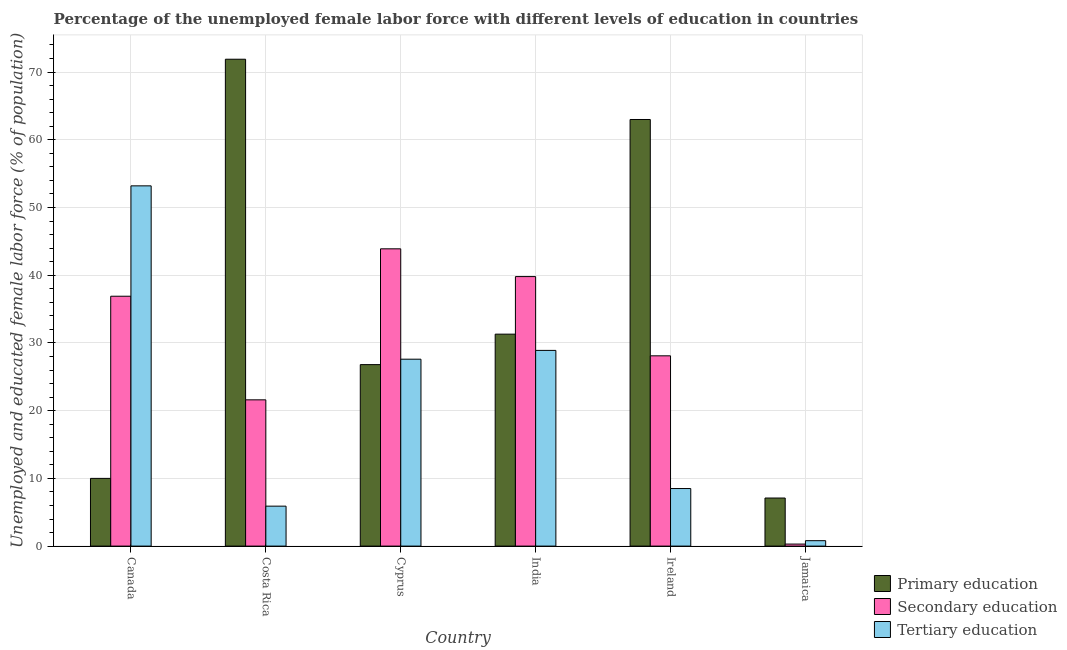How many different coloured bars are there?
Your answer should be compact. 3. How many groups of bars are there?
Your answer should be compact. 6. Are the number of bars on each tick of the X-axis equal?
Your response must be concise. Yes. What is the label of the 1st group of bars from the left?
Offer a terse response. Canada. In how many cases, is the number of bars for a given country not equal to the number of legend labels?
Ensure brevity in your answer.  0. What is the percentage of female labor force who received primary education in Jamaica?
Offer a very short reply. 7.1. Across all countries, what is the maximum percentage of female labor force who received tertiary education?
Your response must be concise. 53.2. Across all countries, what is the minimum percentage of female labor force who received tertiary education?
Provide a short and direct response. 0.8. In which country was the percentage of female labor force who received secondary education minimum?
Offer a terse response. Jamaica. What is the total percentage of female labor force who received secondary education in the graph?
Your answer should be compact. 170.6. What is the difference between the percentage of female labor force who received secondary education in Costa Rica and that in Ireland?
Your answer should be compact. -6.5. What is the difference between the percentage of female labor force who received tertiary education in India and the percentage of female labor force who received primary education in Ireland?
Give a very brief answer. -34.1. What is the average percentage of female labor force who received tertiary education per country?
Ensure brevity in your answer.  20.82. What is the difference between the percentage of female labor force who received secondary education and percentage of female labor force who received tertiary education in Costa Rica?
Your answer should be compact. 15.7. In how many countries, is the percentage of female labor force who received tertiary education greater than 18 %?
Keep it short and to the point. 3. What is the ratio of the percentage of female labor force who received tertiary education in India to that in Ireland?
Give a very brief answer. 3.4. Is the difference between the percentage of female labor force who received tertiary education in Costa Rica and Jamaica greater than the difference between the percentage of female labor force who received secondary education in Costa Rica and Jamaica?
Make the answer very short. No. What is the difference between the highest and the second highest percentage of female labor force who received secondary education?
Offer a terse response. 4.1. What is the difference between the highest and the lowest percentage of female labor force who received secondary education?
Offer a very short reply. 43.6. In how many countries, is the percentage of female labor force who received secondary education greater than the average percentage of female labor force who received secondary education taken over all countries?
Provide a succinct answer. 3. What does the 2nd bar from the left in Jamaica represents?
Your answer should be very brief. Secondary education. Is it the case that in every country, the sum of the percentage of female labor force who received primary education and percentage of female labor force who received secondary education is greater than the percentage of female labor force who received tertiary education?
Your response must be concise. No. How many bars are there?
Your answer should be very brief. 18. Does the graph contain any zero values?
Your answer should be compact. No. Where does the legend appear in the graph?
Make the answer very short. Bottom right. How are the legend labels stacked?
Give a very brief answer. Vertical. What is the title of the graph?
Offer a very short reply. Percentage of the unemployed female labor force with different levels of education in countries. Does "Ages 65 and above" appear as one of the legend labels in the graph?
Your response must be concise. No. What is the label or title of the Y-axis?
Keep it short and to the point. Unemployed and educated female labor force (% of population). What is the Unemployed and educated female labor force (% of population) of Secondary education in Canada?
Offer a very short reply. 36.9. What is the Unemployed and educated female labor force (% of population) in Tertiary education in Canada?
Provide a succinct answer. 53.2. What is the Unemployed and educated female labor force (% of population) in Primary education in Costa Rica?
Make the answer very short. 71.9. What is the Unemployed and educated female labor force (% of population) in Secondary education in Costa Rica?
Offer a very short reply. 21.6. What is the Unemployed and educated female labor force (% of population) of Tertiary education in Costa Rica?
Provide a succinct answer. 5.9. What is the Unemployed and educated female labor force (% of population) in Primary education in Cyprus?
Keep it short and to the point. 26.8. What is the Unemployed and educated female labor force (% of population) of Secondary education in Cyprus?
Your answer should be very brief. 43.9. What is the Unemployed and educated female labor force (% of population) of Tertiary education in Cyprus?
Provide a succinct answer. 27.6. What is the Unemployed and educated female labor force (% of population) in Primary education in India?
Provide a short and direct response. 31.3. What is the Unemployed and educated female labor force (% of population) in Secondary education in India?
Give a very brief answer. 39.8. What is the Unemployed and educated female labor force (% of population) in Tertiary education in India?
Offer a very short reply. 28.9. What is the Unemployed and educated female labor force (% of population) in Secondary education in Ireland?
Give a very brief answer. 28.1. What is the Unemployed and educated female labor force (% of population) in Primary education in Jamaica?
Make the answer very short. 7.1. What is the Unemployed and educated female labor force (% of population) of Secondary education in Jamaica?
Make the answer very short. 0.3. What is the Unemployed and educated female labor force (% of population) of Tertiary education in Jamaica?
Ensure brevity in your answer.  0.8. Across all countries, what is the maximum Unemployed and educated female labor force (% of population) of Primary education?
Your answer should be compact. 71.9. Across all countries, what is the maximum Unemployed and educated female labor force (% of population) of Secondary education?
Your answer should be very brief. 43.9. Across all countries, what is the maximum Unemployed and educated female labor force (% of population) of Tertiary education?
Your response must be concise. 53.2. Across all countries, what is the minimum Unemployed and educated female labor force (% of population) of Primary education?
Your response must be concise. 7.1. Across all countries, what is the minimum Unemployed and educated female labor force (% of population) in Secondary education?
Provide a short and direct response. 0.3. Across all countries, what is the minimum Unemployed and educated female labor force (% of population) of Tertiary education?
Make the answer very short. 0.8. What is the total Unemployed and educated female labor force (% of population) in Primary education in the graph?
Offer a very short reply. 210.1. What is the total Unemployed and educated female labor force (% of population) of Secondary education in the graph?
Provide a short and direct response. 170.6. What is the total Unemployed and educated female labor force (% of population) of Tertiary education in the graph?
Your response must be concise. 124.9. What is the difference between the Unemployed and educated female labor force (% of population) in Primary education in Canada and that in Costa Rica?
Make the answer very short. -61.9. What is the difference between the Unemployed and educated female labor force (% of population) in Secondary education in Canada and that in Costa Rica?
Your answer should be compact. 15.3. What is the difference between the Unemployed and educated female labor force (% of population) in Tertiary education in Canada and that in Costa Rica?
Make the answer very short. 47.3. What is the difference between the Unemployed and educated female labor force (% of population) in Primary education in Canada and that in Cyprus?
Make the answer very short. -16.8. What is the difference between the Unemployed and educated female labor force (% of population) of Tertiary education in Canada and that in Cyprus?
Provide a short and direct response. 25.6. What is the difference between the Unemployed and educated female labor force (% of population) in Primary education in Canada and that in India?
Ensure brevity in your answer.  -21.3. What is the difference between the Unemployed and educated female labor force (% of population) of Secondary education in Canada and that in India?
Offer a very short reply. -2.9. What is the difference between the Unemployed and educated female labor force (% of population) of Tertiary education in Canada and that in India?
Offer a very short reply. 24.3. What is the difference between the Unemployed and educated female labor force (% of population) in Primary education in Canada and that in Ireland?
Ensure brevity in your answer.  -53. What is the difference between the Unemployed and educated female labor force (% of population) in Tertiary education in Canada and that in Ireland?
Your answer should be very brief. 44.7. What is the difference between the Unemployed and educated female labor force (% of population) in Secondary education in Canada and that in Jamaica?
Provide a succinct answer. 36.6. What is the difference between the Unemployed and educated female labor force (% of population) of Tertiary education in Canada and that in Jamaica?
Offer a very short reply. 52.4. What is the difference between the Unemployed and educated female labor force (% of population) in Primary education in Costa Rica and that in Cyprus?
Offer a terse response. 45.1. What is the difference between the Unemployed and educated female labor force (% of population) of Secondary education in Costa Rica and that in Cyprus?
Keep it short and to the point. -22.3. What is the difference between the Unemployed and educated female labor force (% of population) of Tertiary education in Costa Rica and that in Cyprus?
Provide a short and direct response. -21.7. What is the difference between the Unemployed and educated female labor force (% of population) in Primary education in Costa Rica and that in India?
Provide a succinct answer. 40.6. What is the difference between the Unemployed and educated female labor force (% of population) of Secondary education in Costa Rica and that in India?
Provide a succinct answer. -18.2. What is the difference between the Unemployed and educated female labor force (% of population) in Primary education in Costa Rica and that in Ireland?
Your answer should be very brief. 8.9. What is the difference between the Unemployed and educated female labor force (% of population) of Primary education in Costa Rica and that in Jamaica?
Give a very brief answer. 64.8. What is the difference between the Unemployed and educated female labor force (% of population) of Secondary education in Costa Rica and that in Jamaica?
Provide a short and direct response. 21.3. What is the difference between the Unemployed and educated female labor force (% of population) of Tertiary education in Costa Rica and that in Jamaica?
Your response must be concise. 5.1. What is the difference between the Unemployed and educated female labor force (% of population) in Primary education in Cyprus and that in India?
Your answer should be compact. -4.5. What is the difference between the Unemployed and educated female labor force (% of population) in Primary education in Cyprus and that in Ireland?
Your answer should be very brief. -36.2. What is the difference between the Unemployed and educated female labor force (% of population) of Secondary education in Cyprus and that in Jamaica?
Make the answer very short. 43.6. What is the difference between the Unemployed and educated female labor force (% of population) of Tertiary education in Cyprus and that in Jamaica?
Provide a succinct answer. 26.8. What is the difference between the Unemployed and educated female labor force (% of population) of Primary education in India and that in Ireland?
Your response must be concise. -31.7. What is the difference between the Unemployed and educated female labor force (% of population) in Secondary education in India and that in Ireland?
Provide a succinct answer. 11.7. What is the difference between the Unemployed and educated female labor force (% of population) in Tertiary education in India and that in Ireland?
Provide a succinct answer. 20.4. What is the difference between the Unemployed and educated female labor force (% of population) of Primary education in India and that in Jamaica?
Your answer should be very brief. 24.2. What is the difference between the Unemployed and educated female labor force (% of population) of Secondary education in India and that in Jamaica?
Ensure brevity in your answer.  39.5. What is the difference between the Unemployed and educated female labor force (% of population) of Tertiary education in India and that in Jamaica?
Your answer should be compact. 28.1. What is the difference between the Unemployed and educated female labor force (% of population) in Primary education in Ireland and that in Jamaica?
Provide a short and direct response. 55.9. What is the difference between the Unemployed and educated female labor force (% of population) in Secondary education in Ireland and that in Jamaica?
Give a very brief answer. 27.8. What is the difference between the Unemployed and educated female labor force (% of population) of Tertiary education in Ireland and that in Jamaica?
Your answer should be very brief. 7.7. What is the difference between the Unemployed and educated female labor force (% of population) of Primary education in Canada and the Unemployed and educated female labor force (% of population) of Tertiary education in Costa Rica?
Provide a short and direct response. 4.1. What is the difference between the Unemployed and educated female labor force (% of population) in Secondary education in Canada and the Unemployed and educated female labor force (% of population) in Tertiary education in Costa Rica?
Provide a succinct answer. 31. What is the difference between the Unemployed and educated female labor force (% of population) of Primary education in Canada and the Unemployed and educated female labor force (% of population) of Secondary education in Cyprus?
Ensure brevity in your answer.  -33.9. What is the difference between the Unemployed and educated female labor force (% of population) in Primary education in Canada and the Unemployed and educated female labor force (% of population) in Tertiary education in Cyprus?
Give a very brief answer. -17.6. What is the difference between the Unemployed and educated female labor force (% of population) in Primary education in Canada and the Unemployed and educated female labor force (% of population) in Secondary education in India?
Offer a terse response. -29.8. What is the difference between the Unemployed and educated female labor force (% of population) of Primary education in Canada and the Unemployed and educated female labor force (% of population) of Tertiary education in India?
Offer a terse response. -18.9. What is the difference between the Unemployed and educated female labor force (% of population) in Primary education in Canada and the Unemployed and educated female labor force (% of population) in Secondary education in Ireland?
Your response must be concise. -18.1. What is the difference between the Unemployed and educated female labor force (% of population) in Primary education in Canada and the Unemployed and educated female labor force (% of population) in Tertiary education in Ireland?
Provide a succinct answer. 1.5. What is the difference between the Unemployed and educated female labor force (% of population) of Secondary education in Canada and the Unemployed and educated female labor force (% of population) of Tertiary education in Ireland?
Provide a succinct answer. 28.4. What is the difference between the Unemployed and educated female labor force (% of population) of Primary education in Canada and the Unemployed and educated female labor force (% of population) of Secondary education in Jamaica?
Offer a very short reply. 9.7. What is the difference between the Unemployed and educated female labor force (% of population) of Secondary education in Canada and the Unemployed and educated female labor force (% of population) of Tertiary education in Jamaica?
Keep it short and to the point. 36.1. What is the difference between the Unemployed and educated female labor force (% of population) in Primary education in Costa Rica and the Unemployed and educated female labor force (% of population) in Tertiary education in Cyprus?
Provide a short and direct response. 44.3. What is the difference between the Unemployed and educated female labor force (% of population) of Primary education in Costa Rica and the Unemployed and educated female labor force (% of population) of Secondary education in India?
Your answer should be very brief. 32.1. What is the difference between the Unemployed and educated female labor force (% of population) of Primary education in Costa Rica and the Unemployed and educated female labor force (% of population) of Tertiary education in India?
Give a very brief answer. 43. What is the difference between the Unemployed and educated female labor force (% of population) in Primary education in Costa Rica and the Unemployed and educated female labor force (% of population) in Secondary education in Ireland?
Offer a very short reply. 43.8. What is the difference between the Unemployed and educated female labor force (% of population) of Primary education in Costa Rica and the Unemployed and educated female labor force (% of population) of Tertiary education in Ireland?
Offer a very short reply. 63.4. What is the difference between the Unemployed and educated female labor force (% of population) in Primary education in Costa Rica and the Unemployed and educated female labor force (% of population) in Secondary education in Jamaica?
Ensure brevity in your answer.  71.6. What is the difference between the Unemployed and educated female labor force (% of population) of Primary education in Costa Rica and the Unemployed and educated female labor force (% of population) of Tertiary education in Jamaica?
Make the answer very short. 71.1. What is the difference between the Unemployed and educated female labor force (% of population) of Secondary education in Costa Rica and the Unemployed and educated female labor force (% of population) of Tertiary education in Jamaica?
Your answer should be compact. 20.8. What is the difference between the Unemployed and educated female labor force (% of population) in Primary education in Cyprus and the Unemployed and educated female labor force (% of population) in Secondary education in India?
Your answer should be very brief. -13. What is the difference between the Unemployed and educated female labor force (% of population) of Primary education in Cyprus and the Unemployed and educated female labor force (% of population) of Tertiary education in Ireland?
Give a very brief answer. 18.3. What is the difference between the Unemployed and educated female labor force (% of population) in Secondary education in Cyprus and the Unemployed and educated female labor force (% of population) in Tertiary education in Ireland?
Your answer should be compact. 35.4. What is the difference between the Unemployed and educated female labor force (% of population) in Primary education in Cyprus and the Unemployed and educated female labor force (% of population) in Tertiary education in Jamaica?
Keep it short and to the point. 26. What is the difference between the Unemployed and educated female labor force (% of population) of Secondary education in Cyprus and the Unemployed and educated female labor force (% of population) of Tertiary education in Jamaica?
Offer a terse response. 43.1. What is the difference between the Unemployed and educated female labor force (% of population) of Primary education in India and the Unemployed and educated female labor force (% of population) of Secondary education in Ireland?
Provide a short and direct response. 3.2. What is the difference between the Unemployed and educated female labor force (% of population) in Primary education in India and the Unemployed and educated female labor force (% of population) in Tertiary education in Ireland?
Provide a succinct answer. 22.8. What is the difference between the Unemployed and educated female labor force (% of population) in Secondary education in India and the Unemployed and educated female labor force (% of population) in Tertiary education in Ireland?
Your answer should be compact. 31.3. What is the difference between the Unemployed and educated female labor force (% of population) in Primary education in India and the Unemployed and educated female labor force (% of population) in Secondary education in Jamaica?
Ensure brevity in your answer.  31. What is the difference between the Unemployed and educated female labor force (% of population) of Primary education in India and the Unemployed and educated female labor force (% of population) of Tertiary education in Jamaica?
Provide a short and direct response. 30.5. What is the difference between the Unemployed and educated female labor force (% of population) of Primary education in Ireland and the Unemployed and educated female labor force (% of population) of Secondary education in Jamaica?
Your response must be concise. 62.7. What is the difference between the Unemployed and educated female labor force (% of population) in Primary education in Ireland and the Unemployed and educated female labor force (% of population) in Tertiary education in Jamaica?
Keep it short and to the point. 62.2. What is the difference between the Unemployed and educated female labor force (% of population) in Secondary education in Ireland and the Unemployed and educated female labor force (% of population) in Tertiary education in Jamaica?
Your answer should be very brief. 27.3. What is the average Unemployed and educated female labor force (% of population) in Primary education per country?
Your answer should be very brief. 35.02. What is the average Unemployed and educated female labor force (% of population) in Secondary education per country?
Ensure brevity in your answer.  28.43. What is the average Unemployed and educated female labor force (% of population) in Tertiary education per country?
Provide a short and direct response. 20.82. What is the difference between the Unemployed and educated female labor force (% of population) of Primary education and Unemployed and educated female labor force (% of population) of Secondary education in Canada?
Offer a very short reply. -26.9. What is the difference between the Unemployed and educated female labor force (% of population) of Primary education and Unemployed and educated female labor force (% of population) of Tertiary education in Canada?
Ensure brevity in your answer.  -43.2. What is the difference between the Unemployed and educated female labor force (% of population) of Secondary education and Unemployed and educated female labor force (% of population) of Tertiary education in Canada?
Offer a very short reply. -16.3. What is the difference between the Unemployed and educated female labor force (% of population) in Primary education and Unemployed and educated female labor force (% of population) in Secondary education in Costa Rica?
Your answer should be very brief. 50.3. What is the difference between the Unemployed and educated female labor force (% of population) of Primary education and Unemployed and educated female labor force (% of population) of Secondary education in Cyprus?
Your answer should be very brief. -17.1. What is the difference between the Unemployed and educated female labor force (% of population) in Primary education and Unemployed and educated female labor force (% of population) in Tertiary education in Cyprus?
Your response must be concise. -0.8. What is the difference between the Unemployed and educated female labor force (% of population) in Primary education and Unemployed and educated female labor force (% of population) in Secondary education in India?
Your answer should be very brief. -8.5. What is the difference between the Unemployed and educated female labor force (% of population) in Secondary education and Unemployed and educated female labor force (% of population) in Tertiary education in India?
Your answer should be very brief. 10.9. What is the difference between the Unemployed and educated female labor force (% of population) in Primary education and Unemployed and educated female labor force (% of population) in Secondary education in Ireland?
Offer a very short reply. 34.9. What is the difference between the Unemployed and educated female labor force (% of population) of Primary education and Unemployed and educated female labor force (% of population) of Tertiary education in Ireland?
Offer a very short reply. 54.5. What is the difference between the Unemployed and educated female labor force (% of population) in Secondary education and Unemployed and educated female labor force (% of population) in Tertiary education in Ireland?
Keep it short and to the point. 19.6. What is the difference between the Unemployed and educated female labor force (% of population) in Primary education and Unemployed and educated female labor force (% of population) in Tertiary education in Jamaica?
Make the answer very short. 6.3. What is the difference between the Unemployed and educated female labor force (% of population) of Secondary education and Unemployed and educated female labor force (% of population) of Tertiary education in Jamaica?
Your response must be concise. -0.5. What is the ratio of the Unemployed and educated female labor force (% of population) in Primary education in Canada to that in Costa Rica?
Keep it short and to the point. 0.14. What is the ratio of the Unemployed and educated female labor force (% of population) of Secondary education in Canada to that in Costa Rica?
Give a very brief answer. 1.71. What is the ratio of the Unemployed and educated female labor force (% of population) of Tertiary education in Canada to that in Costa Rica?
Your answer should be very brief. 9.02. What is the ratio of the Unemployed and educated female labor force (% of population) of Primary education in Canada to that in Cyprus?
Provide a short and direct response. 0.37. What is the ratio of the Unemployed and educated female labor force (% of population) in Secondary education in Canada to that in Cyprus?
Ensure brevity in your answer.  0.84. What is the ratio of the Unemployed and educated female labor force (% of population) of Tertiary education in Canada to that in Cyprus?
Keep it short and to the point. 1.93. What is the ratio of the Unemployed and educated female labor force (% of population) of Primary education in Canada to that in India?
Make the answer very short. 0.32. What is the ratio of the Unemployed and educated female labor force (% of population) of Secondary education in Canada to that in India?
Offer a very short reply. 0.93. What is the ratio of the Unemployed and educated female labor force (% of population) in Tertiary education in Canada to that in India?
Ensure brevity in your answer.  1.84. What is the ratio of the Unemployed and educated female labor force (% of population) in Primary education in Canada to that in Ireland?
Keep it short and to the point. 0.16. What is the ratio of the Unemployed and educated female labor force (% of population) of Secondary education in Canada to that in Ireland?
Offer a terse response. 1.31. What is the ratio of the Unemployed and educated female labor force (% of population) in Tertiary education in Canada to that in Ireland?
Your response must be concise. 6.26. What is the ratio of the Unemployed and educated female labor force (% of population) in Primary education in Canada to that in Jamaica?
Offer a very short reply. 1.41. What is the ratio of the Unemployed and educated female labor force (% of population) in Secondary education in Canada to that in Jamaica?
Keep it short and to the point. 123. What is the ratio of the Unemployed and educated female labor force (% of population) of Tertiary education in Canada to that in Jamaica?
Your response must be concise. 66.5. What is the ratio of the Unemployed and educated female labor force (% of population) of Primary education in Costa Rica to that in Cyprus?
Provide a short and direct response. 2.68. What is the ratio of the Unemployed and educated female labor force (% of population) of Secondary education in Costa Rica to that in Cyprus?
Offer a terse response. 0.49. What is the ratio of the Unemployed and educated female labor force (% of population) of Tertiary education in Costa Rica to that in Cyprus?
Provide a short and direct response. 0.21. What is the ratio of the Unemployed and educated female labor force (% of population) in Primary education in Costa Rica to that in India?
Offer a terse response. 2.3. What is the ratio of the Unemployed and educated female labor force (% of population) of Secondary education in Costa Rica to that in India?
Offer a terse response. 0.54. What is the ratio of the Unemployed and educated female labor force (% of population) in Tertiary education in Costa Rica to that in India?
Give a very brief answer. 0.2. What is the ratio of the Unemployed and educated female labor force (% of population) in Primary education in Costa Rica to that in Ireland?
Offer a terse response. 1.14. What is the ratio of the Unemployed and educated female labor force (% of population) of Secondary education in Costa Rica to that in Ireland?
Your answer should be compact. 0.77. What is the ratio of the Unemployed and educated female labor force (% of population) of Tertiary education in Costa Rica to that in Ireland?
Give a very brief answer. 0.69. What is the ratio of the Unemployed and educated female labor force (% of population) in Primary education in Costa Rica to that in Jamaica?
Provide a short and direct response. 10.13. What is the ratio of the Unemployed and educated female labor force (% of population) in Secondary education in Costa Rica to that in Jamaica?
Your response must be concise. 72. What is the ratio of the Unemployed and educated female labor force (% of population) of Tertiary education in Costa Rica to that in Jamaica?
Provide a succinct answer. 7.38. What is the ratio of the Unemployed and educated female labor force (% of population) in Primary education in Cyprus to that in India?
Your response must be concise. 0.86. What is the ratio of the Unemployed and educated female labor force (% of population) of Secondary education in Cyprus to that in India?
Your answer should be very brief. 1.1. What is the ratio of the Unemployed and educated female labor force (% of population) in Tertiary education in Cyprus to that in India?
Your answer should be compact. 0.95. What is the ratio of the Unemployed and educated female labor force (% of population) of Primary education in Cyprus to that in Ireland?
Keep it short and to the point. 0.43. What is the ratio of the Unemployed and educated female labor force (% of population) of Secondary education in Cyprus to that in Ireland?
Offer a very short reply. 1.56. What is the ratio of the Unemployed and educated female labor force (% of population) in Tertiary education in Cyprus to that in Ireland?
Your answer should be very brief. 3.25. What is the ratio of the Unemployed and educated female labor force (% of population) in Primary education in Cyprus to that in Jamaica?
Provide a succinct answer. 3.77. What is the ratio of the Unemployed and educated female labor force (% of population) in Secondary education in Cyprus to that in Jamaica?
Offer a very short reply. 146.33. What is the ratio of the Unemployed and educated female labor force (% of population) of Tertiary education in Cyprus to that in Jamaica?
Offer a terse response. 34.5. What is the ratio of the Unemployed and educated female labor force (% of population) in Primary education in India to that in Ireland?
Give a very brief answer. 0.5. What is the ratio of the Unemployed and educated female labor force (% of population) of Secondary education in India to that in Ireland?
Make the answer very short. 1.42. What is the ratio of the Unemployed and educated female labor force (% of population) in Tertiary education in India to that in Ireland?
Your response must be concise. 3.4. What is the ratio of the Unemployed and educated female labor force (% of population) in Primary education in India to that in Jamaica?
Give a very brief answer. 4.41. What is the ratio of the Unemployed and educated female labor force (% of population) in Secondary education in India to that in Jamaica?
Offer a terse response. 132.67. What is the ratio of the Unemployed and educated female labor force (% of population) in Tertiary education in India to that in Jamaica?
Provide a succinct answer. 36.12. What is the ratio of the Unemployed and educated female labor force (% of population) in Primary education in Ireland to that in Jamaica?
Keep it short and to the point. 8.87. What is the ratio of the Unemployed and educated female labor force (% of population) of Secondary education in Ireland to that in Jamaica?
Offer a terse response. 93.67. What is the ratio of the Unemployed and educated female labor force (% of population) of Tertiary education in Ireland to that in Jamaica?
Ensure brevity in your answer.  10.62. What is the difference between the highest and the second highest Unemployed and educated female labor force (% of population) in Primary education?
Offer a very short reply. 8.9. What is the difference between the highest and the second highest Unemployed and educated female labor force (% of population) in Secondary education?
Your answer should be very brief. 4.1. What is the difference between the highest and the second highest Unemployed and educated female labor force (% of population) of Tertiary education?
Your answer should be compact. 24.3. What is the difference between the highest and the lowest Unemployed and educated female labor force (% of population) in Primary education?
Your answer should be very brief. 64.8. What is the difference between the highest and the lowest Unemployed and educated female labor force (% of population) of Secondary education?
Ensure brevity in your answer.  43.6. What is the difference between the highest and the lowest Unemployed and educated female labor force (% of population) of Tertiary education?
Your response must be concise. 52.4. 